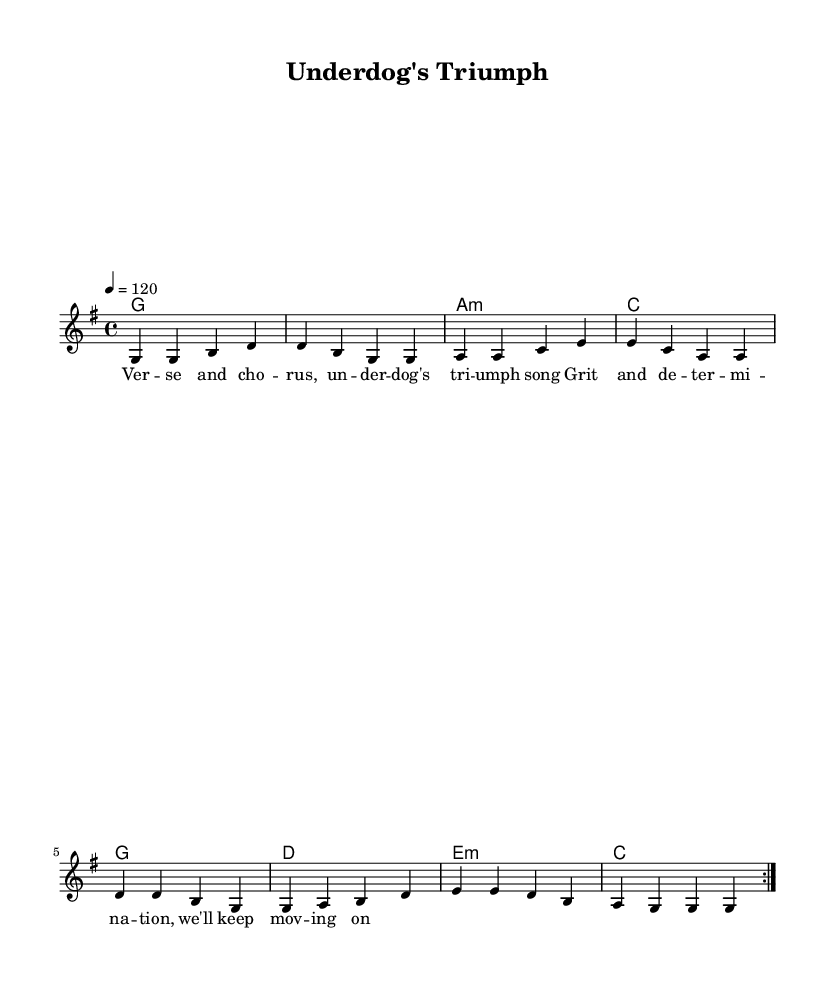What is the key signature of this music? The key signature is G major, which has one sharp (F#) indicated on the staff.
Answer: G major What is the time signature of this sheet music? The time signature is indicated at the beginning of the score as 4/4, which means there are four beats per measure.
Answer: 4/4 What is the tempo marking for this piece? The tempo marking indicates a speed of 120 beats per minute, noted at the top of the score as "4 = 120."
Answer: 120 How many measures are repeated in the melody section? The melody section repeats a total of two measures, as indicated by the "repeat volta 2" at the beginning of the section.
Answer: 2 measures Which chord appears at the start of the harmony section? The harmony section begins with a G major chord, notated in the first measure of the chord mode.
Answer: G What thematic focus does this piece embody, given its title? The title "Underdog's Triumph" suggests themes of perseverance and overcoming obstacles, common in country rock anthems.
Answer: Perseverance Which lyrics reflect the underdog spirit in the song? The lyrics "Grit and determination, we'll keep moving on" express the determination of an underdog, reinforcing the theme.
Answer: Grit and determination 